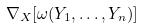Convert formula to latex. <formula><loc_0><loc_0><loc_500><loc_500>\nabla _ { X } [ \omega ( Y _ { 1 } , \dots , Y _ { n } ) ]</formula> 